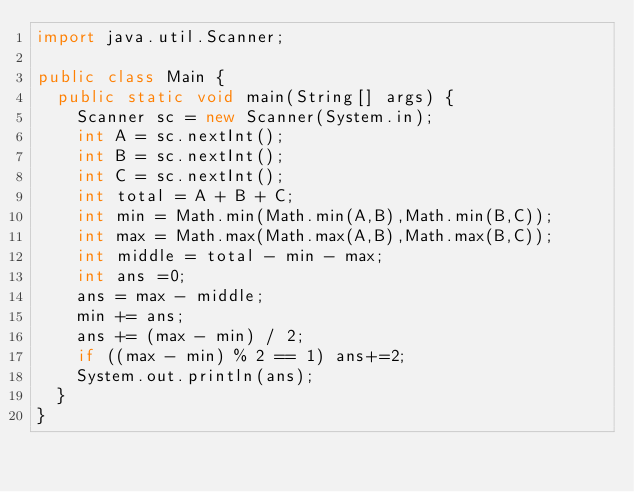<code> <loc_0><loc_0><loc_500><loc_500><_Java_>import java.util.Scanner;

public class Main { 
  public static void main(String[] args) {
    Scanner sc = new Scanner(System.in);
    int A = sc.nextInt();
    int B = sc.nextInt();
    int C = sc.nextInt();
    int total = A + B + C;
    int min = Math.min(Math.min(A,B),Math.min(B,C));
    int max = Math.max(Math.max(A,B),Math.max(B,C));
    int middle = total - min - max;
    int ans =0;
    ans = max - middle;
    min += ans;
    ans += (max - min) / 2;
    if ((max - min) % 2 == 1) ans+=2;
    System.out.println(ans);
  }
}    </code> 